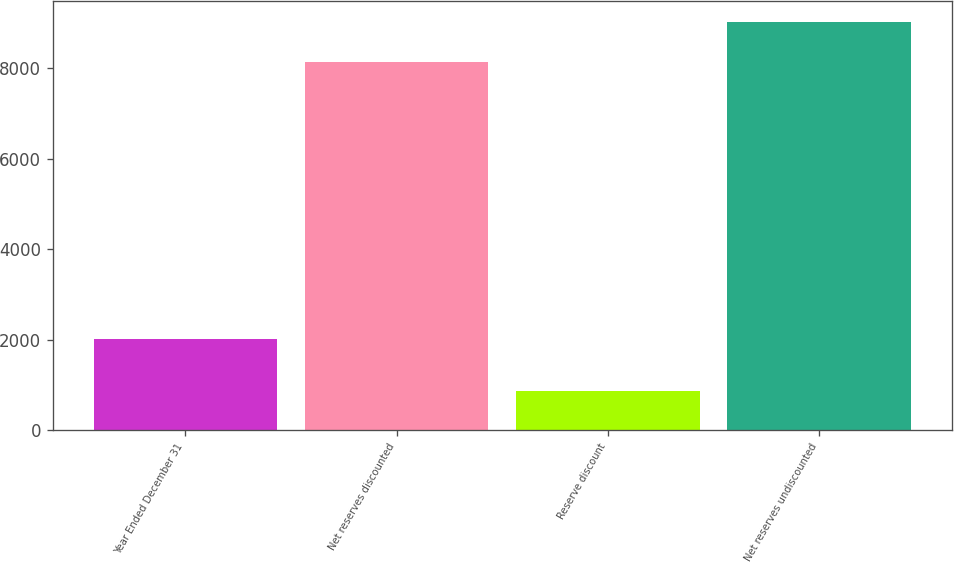Convert chart. <chart><loc_0><loc_0><loc_500><loc_500><bar_chart><fcel>Year Ended December 31<fcel>Net reserves discounted<fcel>Reserve discount<fcel>Net reserves undiscounted<nl><fcel>2009<fcel>8148<fcel>877<fcel>9025<nl></chart> 